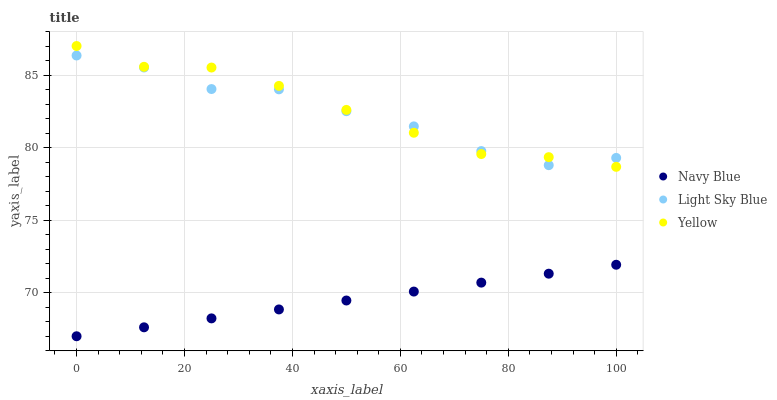Does Navy Blue have the minimum area under the curve?
Answer yes or no. Yes. Does Yellow have the maximum area under the curve?
Answer yes or no. Yes. Does Light Sky Blue have the minimum area under the curve?
Answer yes or no. No. Does Light Sky Blue have the maximum area under the curve?
Answer yes or no. No. Is Navy Blue the smoothest?
Answer yes or no. Yes. Is Light Sky Blue the roughest?
Answer yes or no. Yes. Is Yellow the smoothest?
Answer yes or no. No. Is Yellow the roughest?
Answer yes or no. No. Does Navy Blue have the lowest value?
Answer yes or no. Yes. Does Yellow have the lowest value?
Answer yes or no. No. Does Yellow have the highest value?
Answer yes or no. Yes. Does Light Sky Blue have the highest value?
Answer yes or no. No. Is Navy Blue less than Yellow?
Answer yes or no. Yes. Is Yellow greater than Navy Blue?
Answer yes or no. Yes. Does Yellow intersect Light Sky Blue?
Answer yes or no. Yes. Is Yellow less than Light Sky Blue?
Answer yes or no. No. Is Yellow greater than Light Sky Blue?
Answer yes or no. No. Does Navy Blue intersect Yellow?
Answer yes or no. No. 